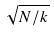<formula> <loc_0><loc_0><loc_500><loc_500>\sqrt { N / k }</formula> 